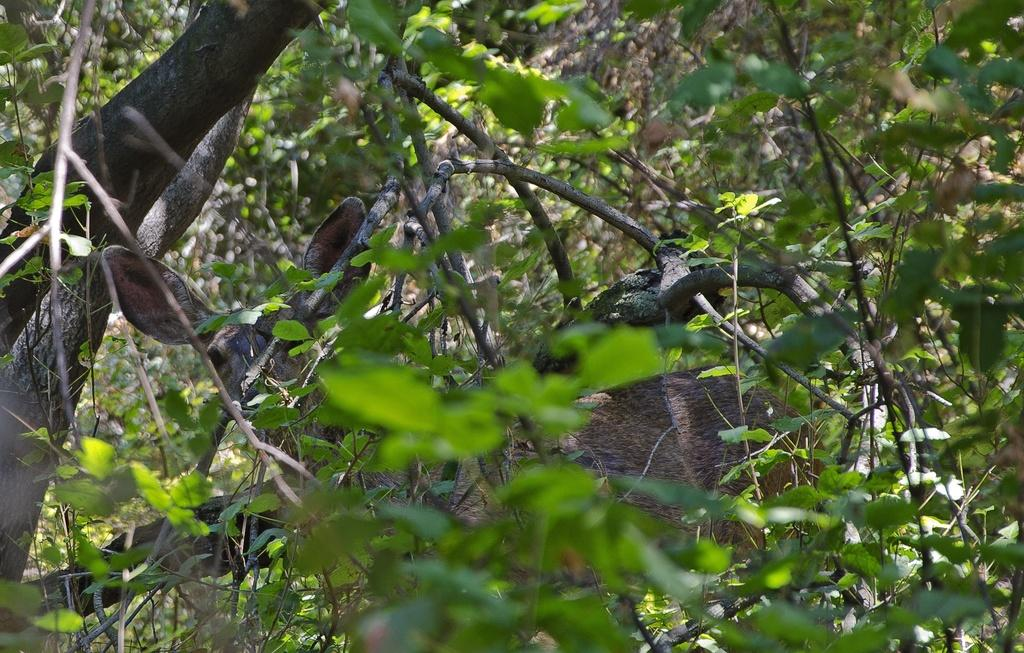What type of animal can be seen in the image? There is an animal in the image, but its specific type cannot be determined from the provided facts. Where is the animal located in the image? The animal is sitting on a branch of a tree. What can be seen in the background of the image? There are many leaves and branches visible in the image. What is the name of the chin that the animal is holding in the image? There is no chin present in the image, and the animal is not holding anything. What month does the image depict? The month cannot be determined from the image or the provided facts. 